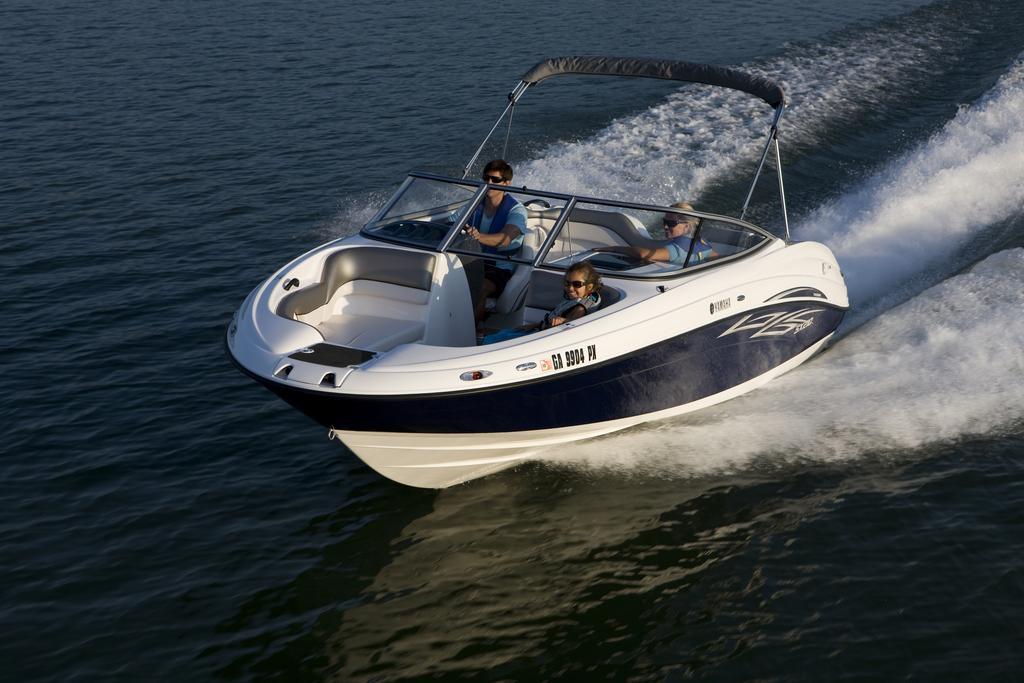In one or two sentences, can you explain what this image depicts? In this image we can see persons sitting in the steamer on the sea. 